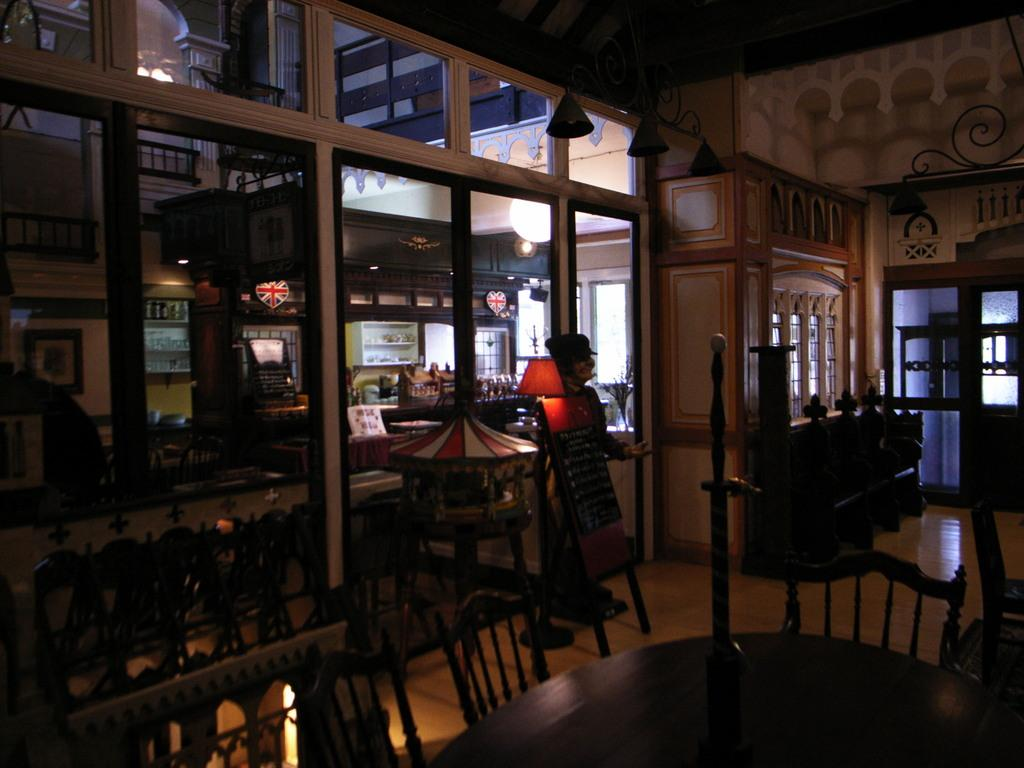What type of furniture is present in the image? There are tables, chairs, and cupboards with drawers in the image. What type of lighting is present in the image? There are light lamps in the image. What material is the floor made of? The floor is made of wood. What type of windows and doors are present in the image? There are windows with glass panes and doors with glass panes in the image. What type of country can be seen in the image? There is no country visible in the image; it features indoor furniture and lighting. How does the wave interact with the tables in the image? There is no wave present in the image; it features indoor furniture and lighting. 